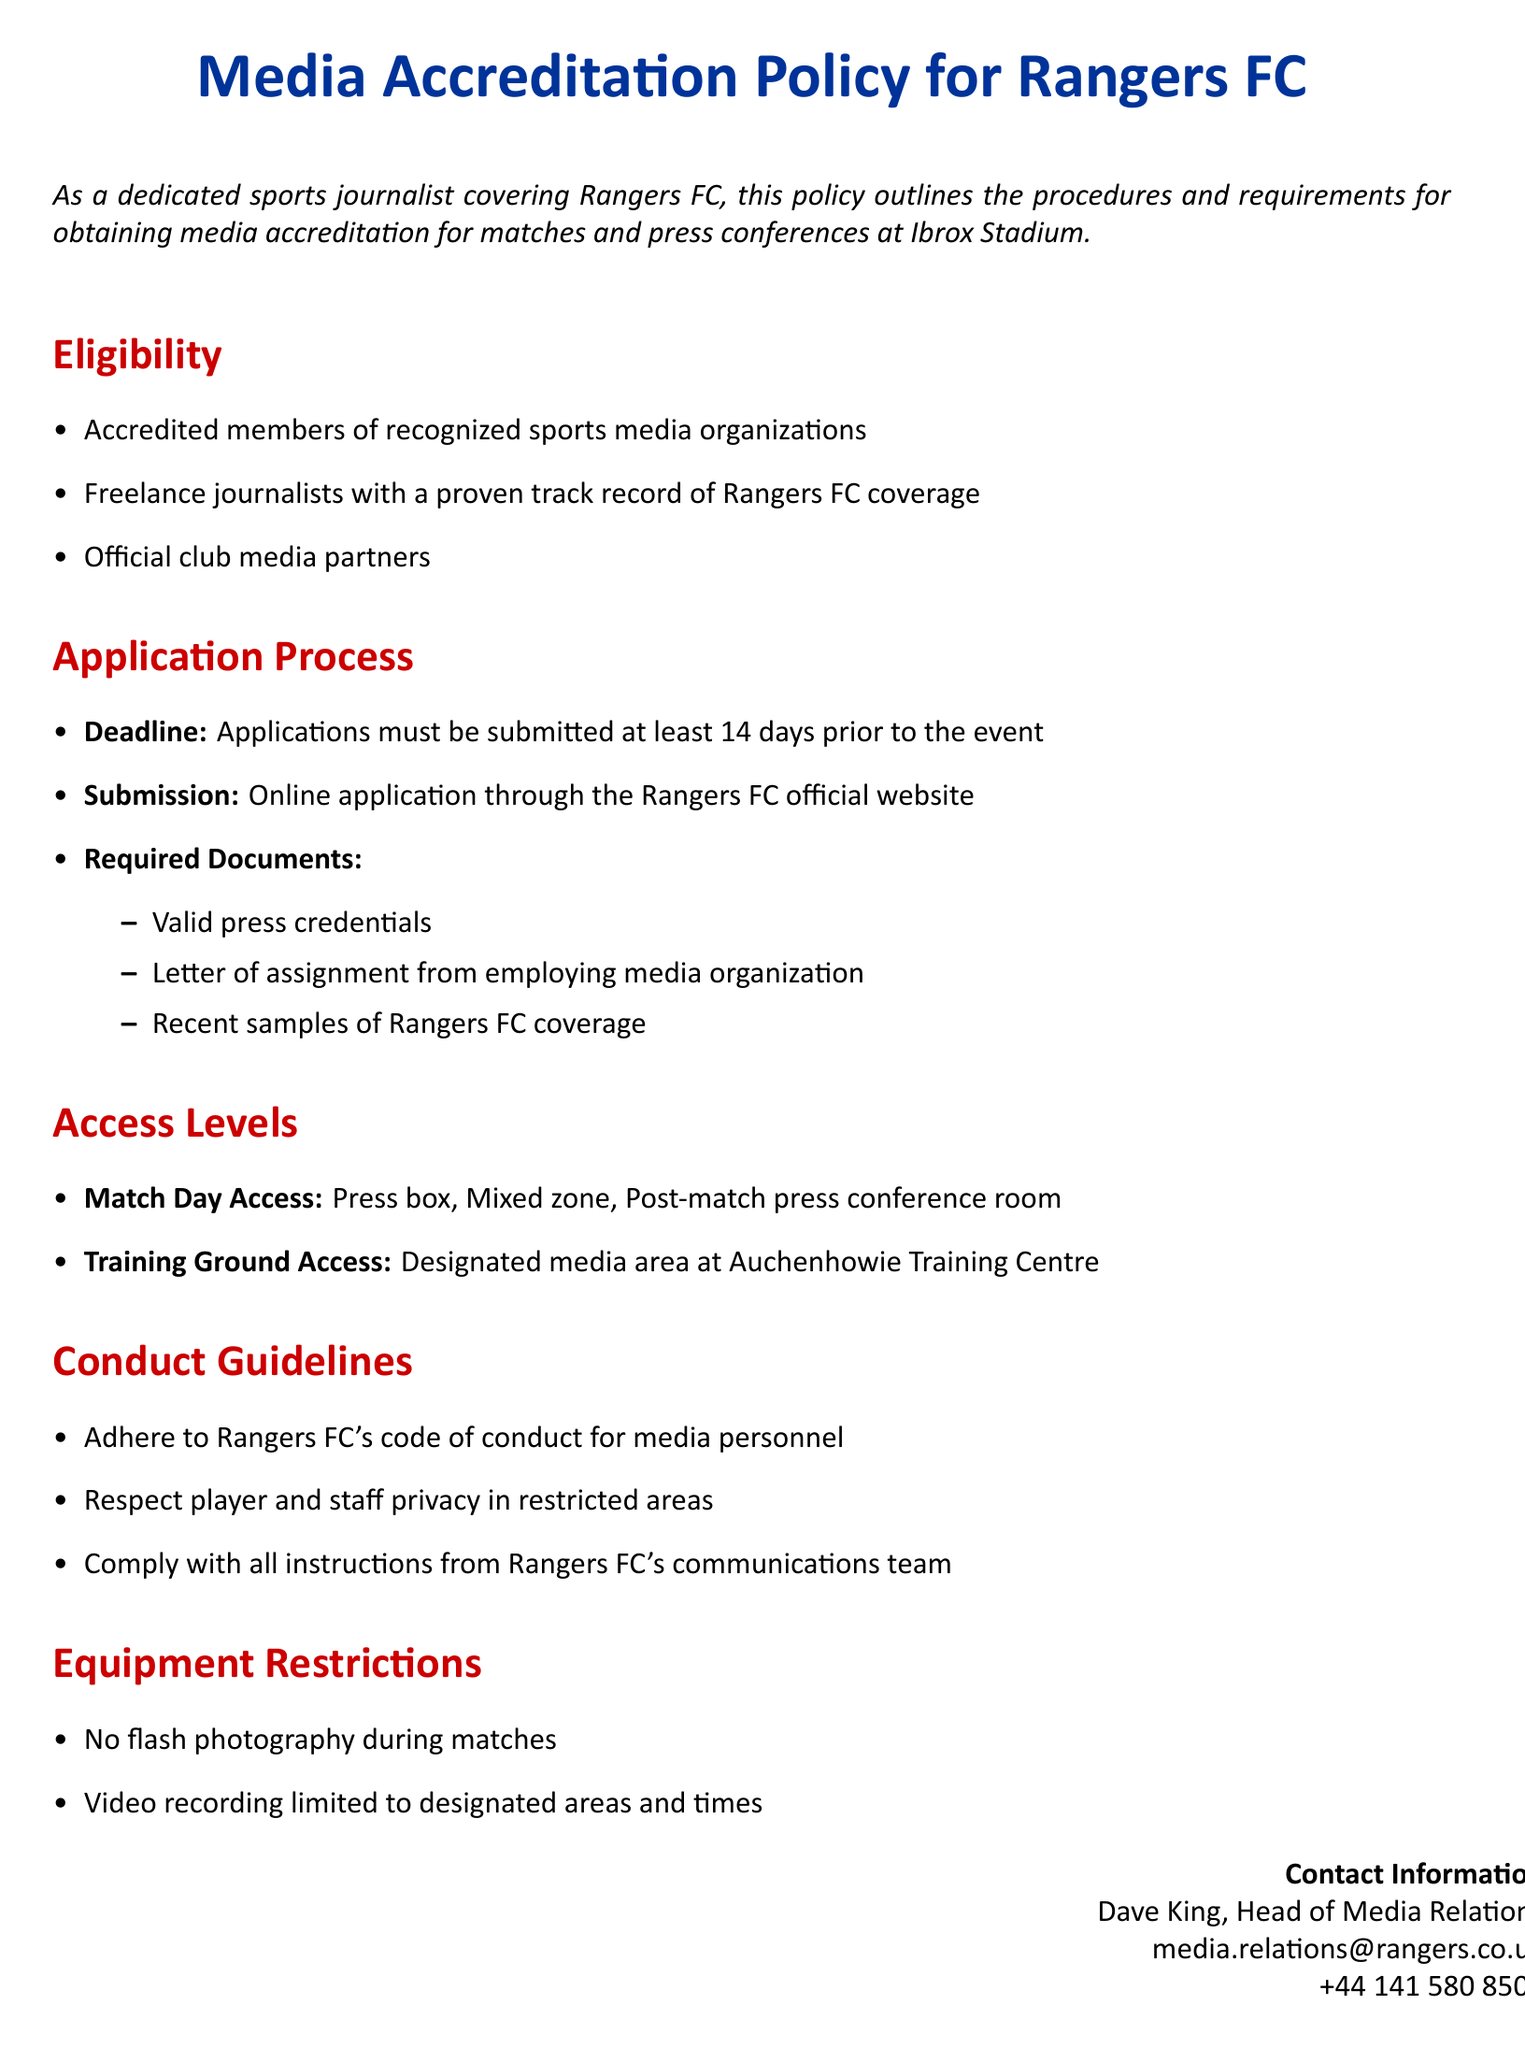What is the title of the document? The title of the document is provided at the beginning of the text, outlining the specific subject of the content.
Answer: Media Accreditation Policy for Rangers FC How many days in advance must applications be submitted? The document specifies that applications must be submitted at least 14 days before the event, indicating the necessary timeline for submission.
Answer: 14 days Who is the Head of Media Relations? The document provides contact information, including the name and title of the person responsible for media relations at Rangers FC.
Answer: Dave King What types of media representatives are eligible for accreditation? The document lists three categories of eligible media representatives in the eligibility section, outlining who can apply for accreditation.
Answer: Accredited members of recognized sports media organizations, freelance journalists with a proven track record of Rangers FC coverage, official club media partners What is prohibited during matches according to the equipment restrictions? The document mentions a specific restriction regarding photography during matches, which highlights a rule for accredited media personnel.
Answer: No flash photography What areas are included in Match Day Access? The document details the specific areas that journalists can access on match days, which showcases the privileges granted to accredited journalists.
Answer: Press box, Mixed zone, Post-match press conference room What must applicants submit along with their application? The document outlines the required documents that need to be provided as part of the application process, indicating what is necessary for approval.
Answer: Valid press credentials, Letter of assignment from employing media organization, Recent samples of Rangers FC coverage What are the conduct guidelines for media personnel? The conduct guidelines section describes the expectations for behavior and actions of media representatives while covering the club, emphasizing professionalism.
Answer: Adhere to Rangers FC's code of conduct for media personnel, Respect player and staff privacy in restricted areas, Comply with all instructions from Rangers FC's communications team 